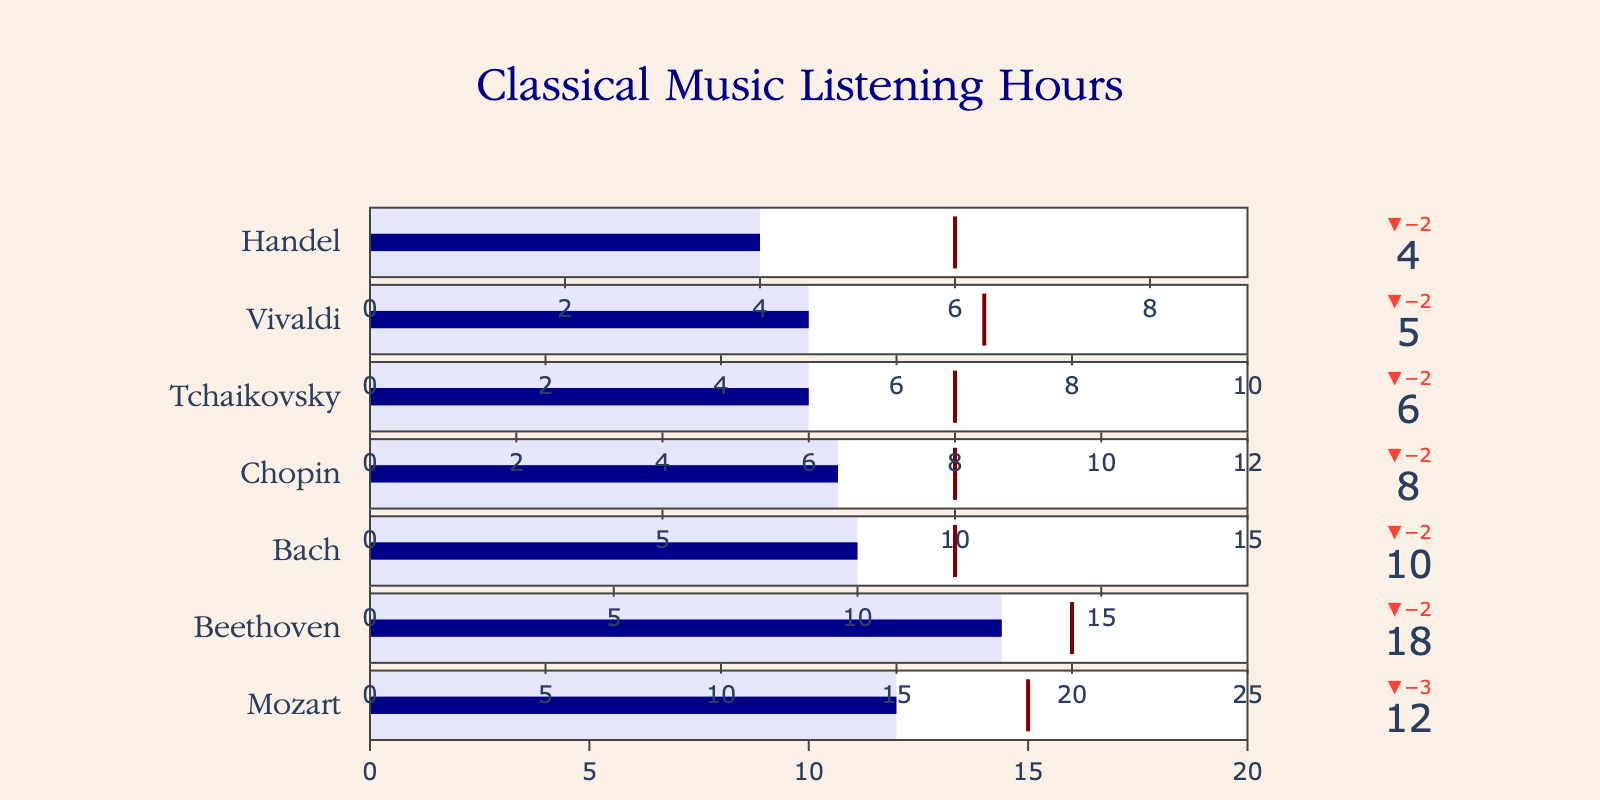What's the title of the figure? The title is displayed at the top of the figure, typically indicating the overall theme or focus. In this case, the title is "Classical Music Listening Hours".
Answer: Classical Music Listening Hours Which composer has the highest number of actual listening hours? To determine this, look at the "Actual Hours" for each composer and identify the one with the highest value. Beethoven has 18 actual hours, which is the highest among all composers listed.
Answer: Beethoven How much more time did I listen to Beethoven compared to Tchaikovsky? Subtract Tchaikovsky's actual hours (6) from Beethoven's actual hours (18). The difference is 18 - 6 hours.
Answer: 12 hours Which composer's actual listening hours fell the furthest short of the target? To find this, calculate the differences between the target hours and actual hours for each composer. Handel's difference is the largest, with a target of 6 hours and actual of 4 hours, resulting in a shortfall of 2 hours.
Answer: Handel What is the total listening time for Mozart, Beethoven, and Vivaldi combined? Sum the actual hours for Mozart (12), Beethoven (18), and Vivaldi (5). The total is 12 + 18 + 5 = 35 hours.
Answer: 35 hours How many composers have met or exceeded their target listening hours? Compare the actual and target hours for each composer. None of the composers listed have met or exceeded their target hours.
Answer: 0 composers Is there a composer for whom the actual listening hours exactly match the target hours? Check if any composer's actual hours are the same as their target hours. None of the composers have actual hours equal to their target hours.
Answer: No What percentage of the maximum possible listening hours did I achieve for Bach? To find the percentage, divide Bach's actual hours (10) by his maximum hours (18) and multiply by 100. So, (10 / 18) * 100 = 55.56%.
Answer: 55.56% Among the listed composers, who has the smallest range between the actual and target hours? Determine the difference between actual and target hours for each composer and identify the smallest value. Handel has the smallest difference of 2 hours (6 - 4).
Answer: Handel 